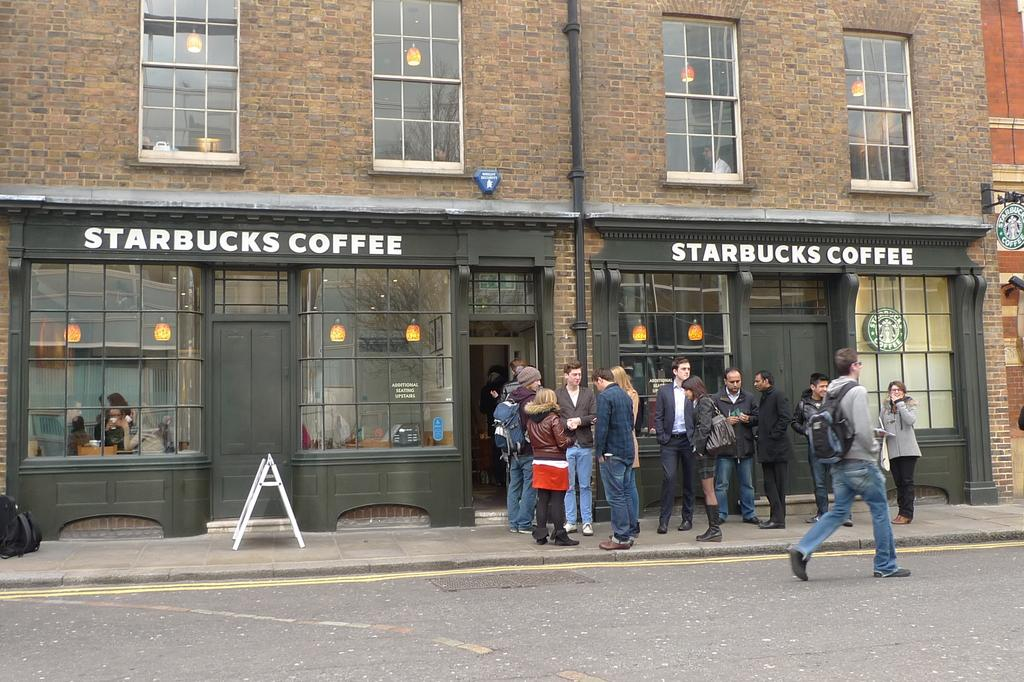What can be seen on the road in the image? There are persons on the road in the image. What type of lighting is present in the image? There are electric lights in the image. What structure is visible in the image? There is a building in the image. What architectural feature can be seen in the building? There are windows in the image. What type of infrastructure is present in the image? There is a pipeline in the image. What safety measure is present in the image? There is a caution board in the image. What type of trees can be seen growing around the pipeline in the image? There are no trees visible in the image; it only shows a pipeline, a caution board, and a building with windows. Can you provide an example of a wool product that is present in the image? There is no wool product present in the image. 